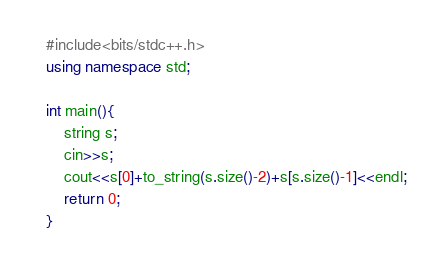<code> <loc_0><loc_0><loc_500><loc_500><_C++_>#include<bits/stdc++.h>
using namespace std;

int main(){
    string s;
    cin>>s;
    cout<<s[0]+to_string(s.size()-2)+s[s.size()-1]<<endl;
    return 0;
}</code> 